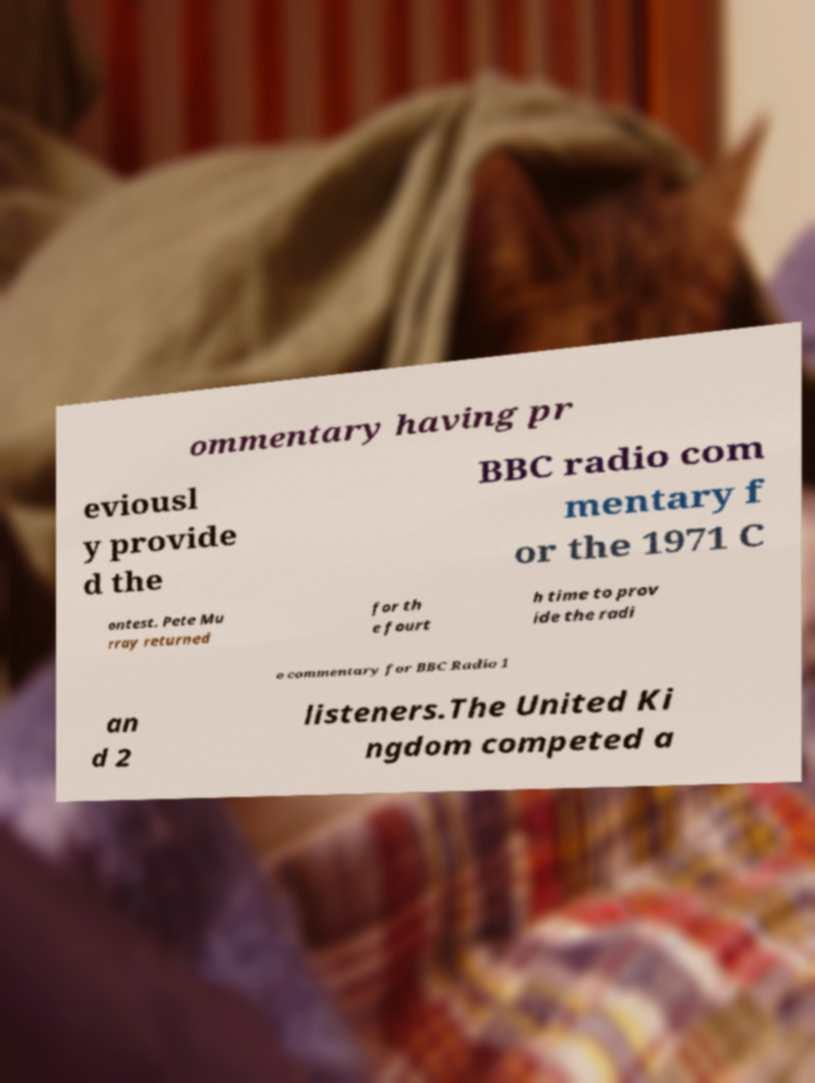Please read and relay the text visible in this image. What does it say? ommentary having pr eviousl y provide d the BBC radio com mentary f or the 1971 C ontest. Pete Mu rray returned for th e fourt h time to prov ide the radi o commentary for BBC Radio 1 an d 2 listeners.The United Ki ngdom competed a 